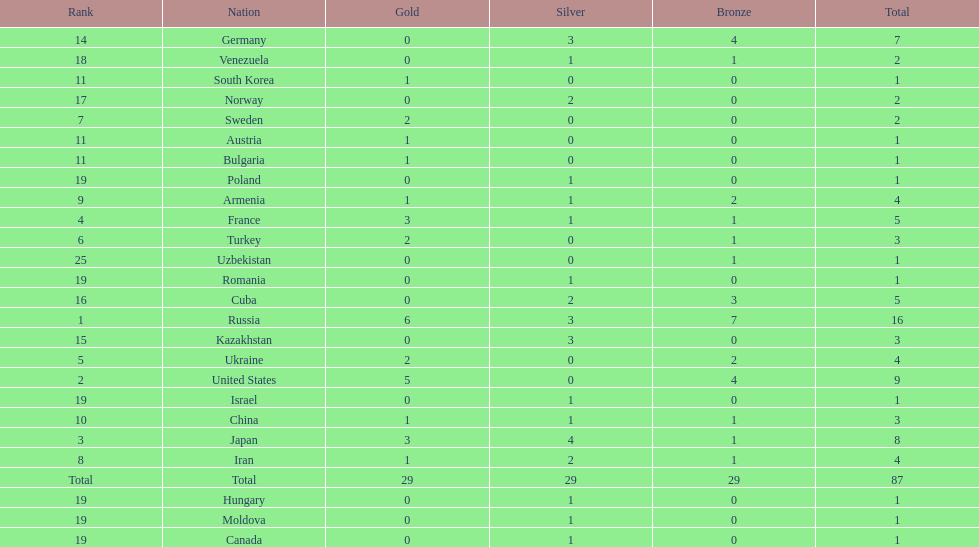Japan and france each won how many gold medals? 3. 